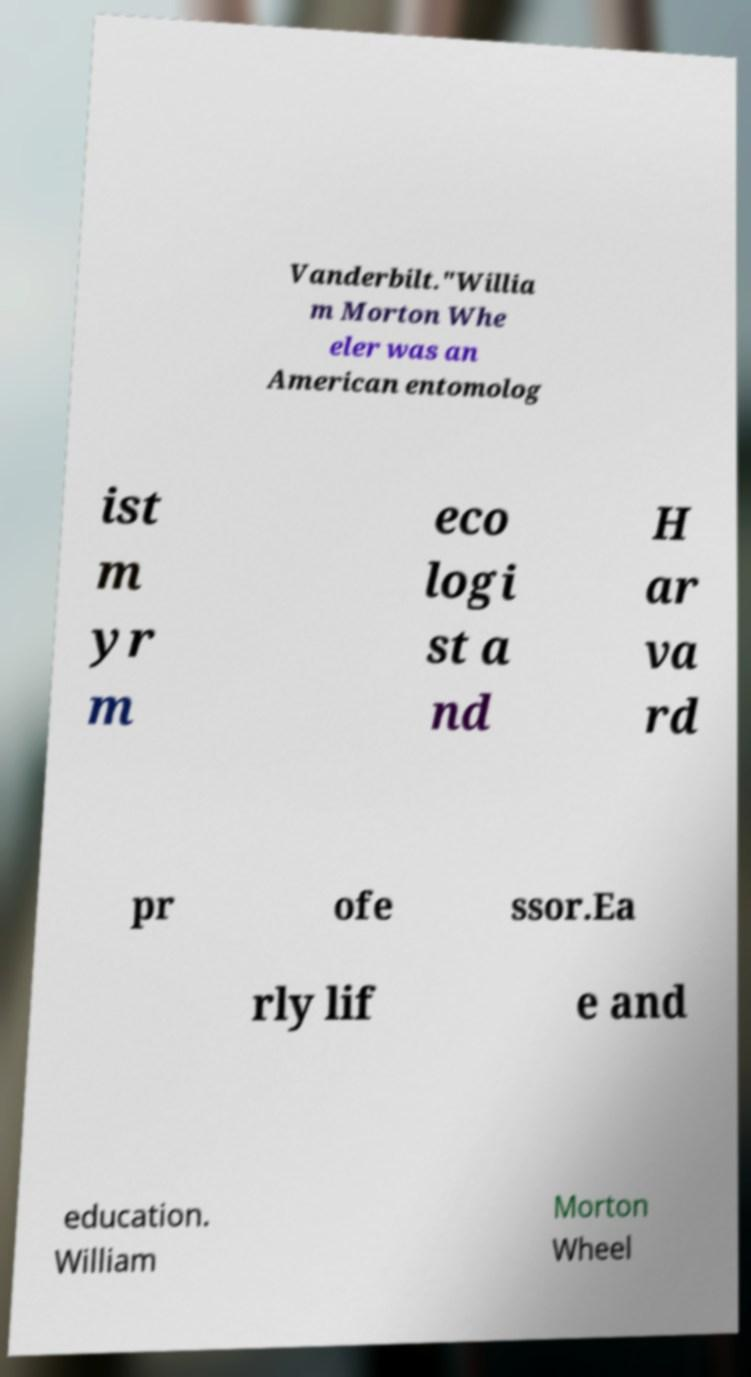Please read and relay the text visible in this image. What does it say? Vanderbilt."Willia m Morton Whe eler was an American entomolog ist m yr m eco logi st a nd H ar va rd pr ofe ssor.Ea rly lif e and education. William Morton Wheel 